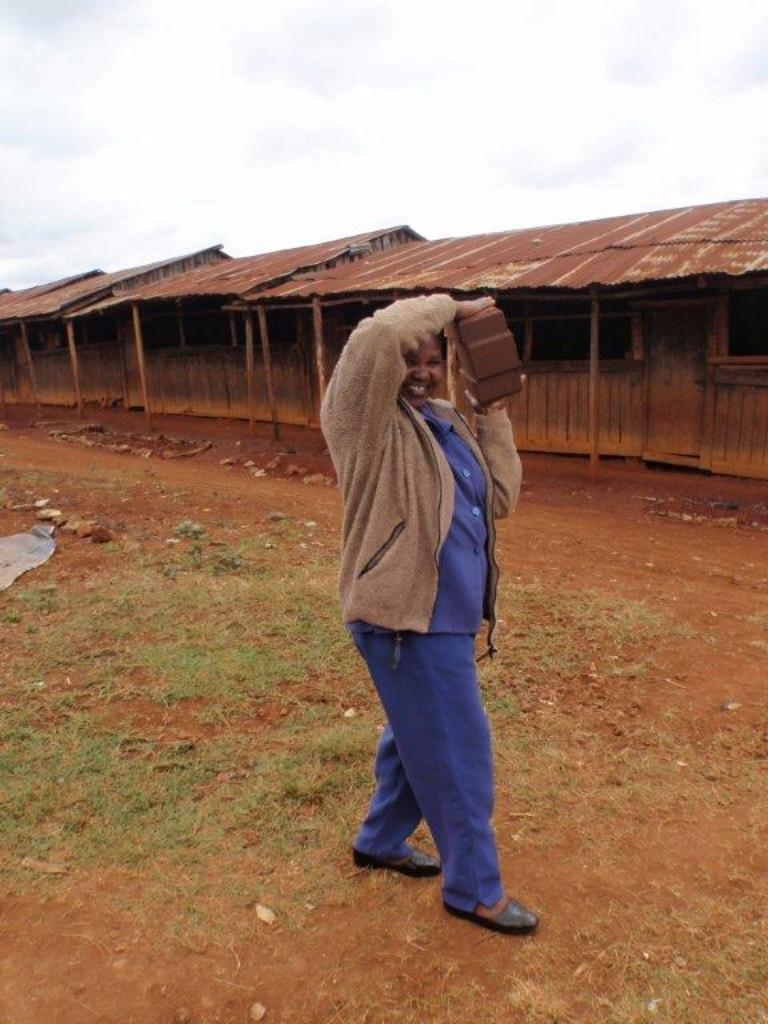Who is present in the image? There are women in the image. What are the women wearing? The women are wearing blue dresses and brown jackets. What are the women doing in the image? The women are standing and holding bricks in their hands. What can be seen in the background of the image? There are houses and a clear sky in the background of the image. What type of baseball game is being played in the image? There is no baseball game present in the image; it features women holding bricks and standing near houses. What ingredients are used to make the stew in the image? There is no stew present in the image; it features women holding bricks and standing near houses. 